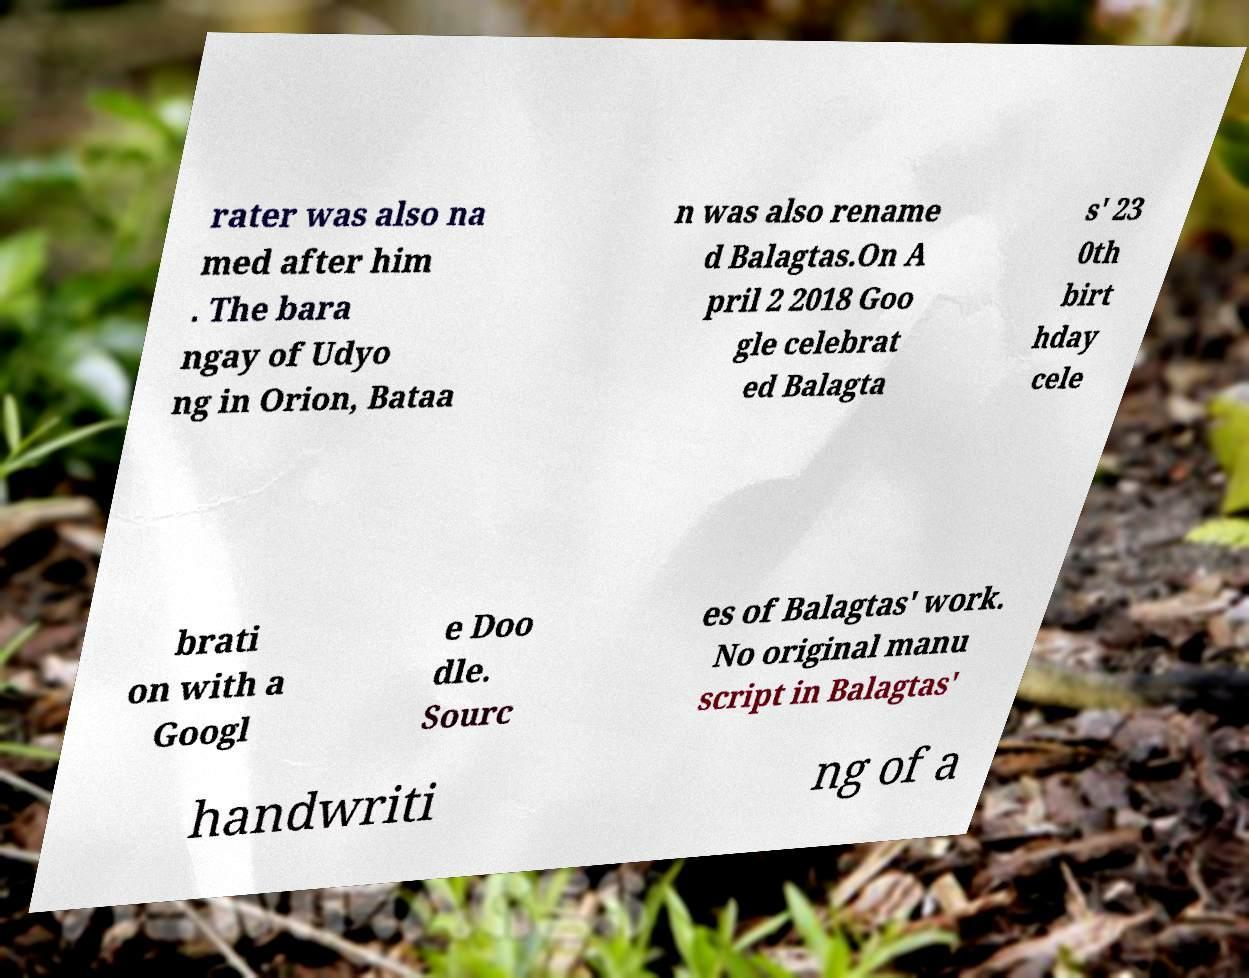Please identify and transcribe the text found in this image. rater was also na med after him . The bara ngay of Udyo ng in Orion, Bataa n was also rename d Balagtas.On A pril 2 2018 Goo gle celebrat ed Balagta s' 23 0th birt hday cele brati on with a Googl e Doo dle. Sourc es of Balagtas' work. No original manu script in Balagtas' handwriti ng of a 